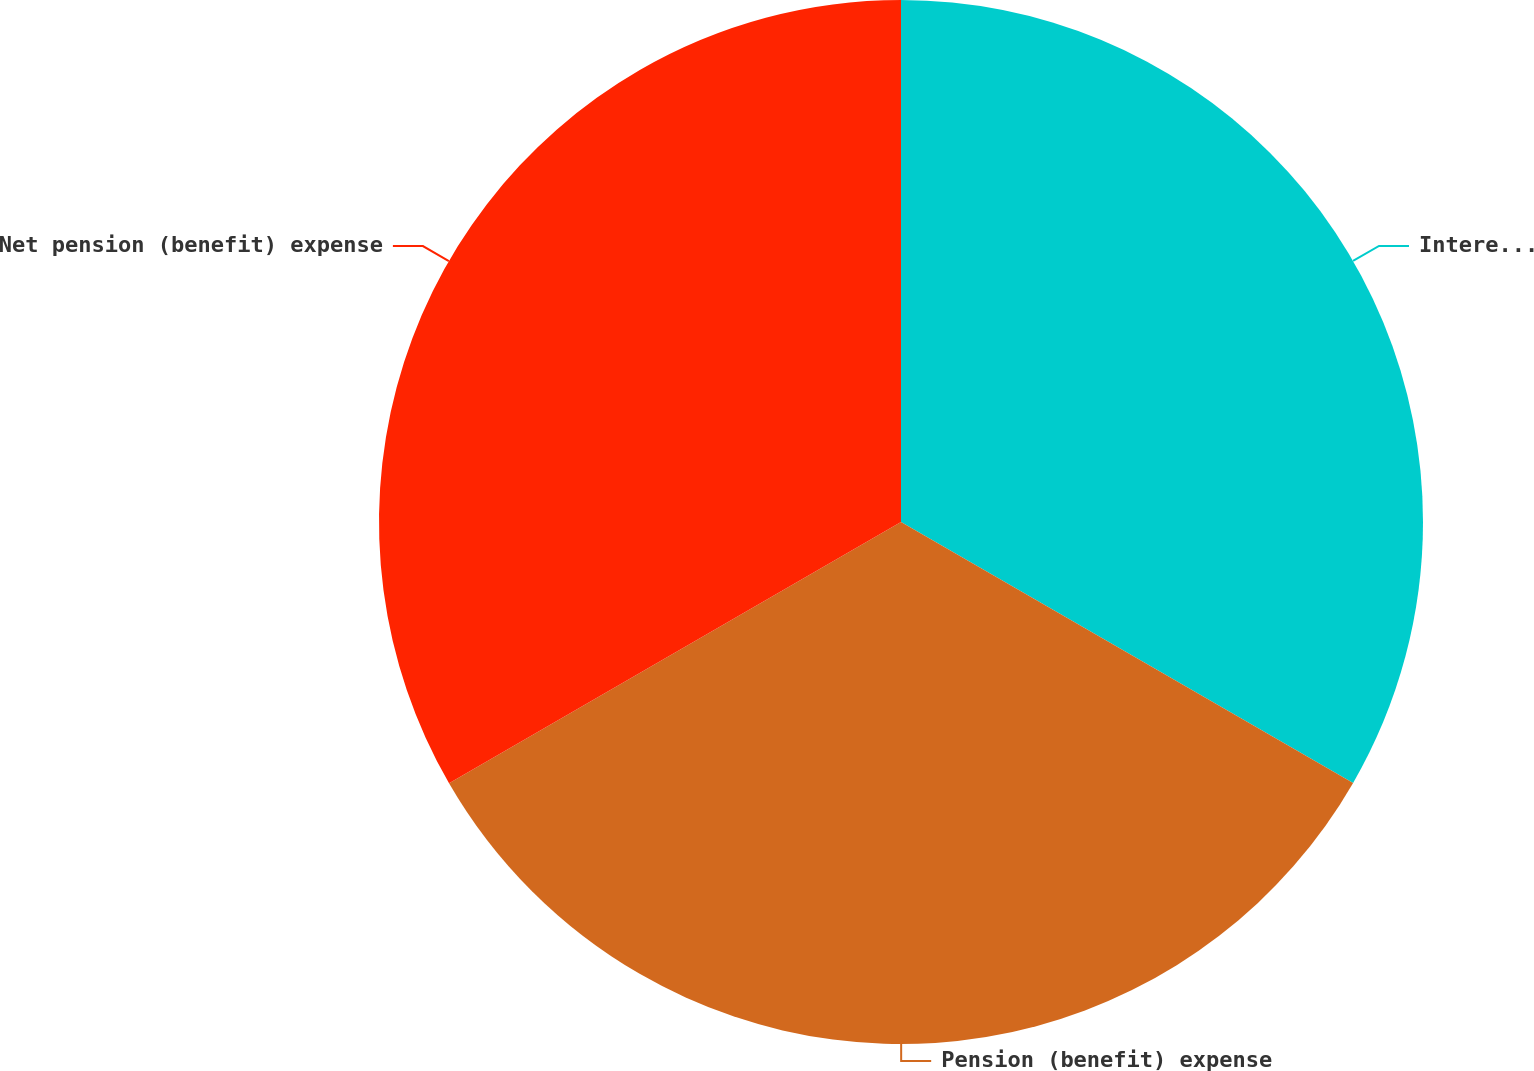<chart> <loc_0><loc_0><loc_500><loc_500><pie_chart><fcel>Interest cost<fcel>Pension (benefit) expense<fcel>Net pension (benefit) expense<nl><fcel>33.33%<fcel>33.33%<fcel>33.34%<nl></chart> 